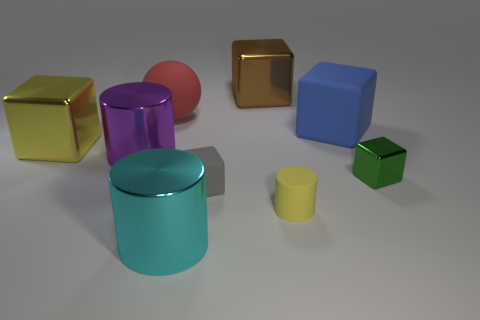How many other things are there of the same color as the rubber cylinder?
Give a very brief answer. 1. There is a cyan metallic cylinder; is it the same size as the yellow object that is in front of the yellow metallic object?
Your answer should be compact. No. What number of yellow matte things are there?
Keep it short and to the point. 1. Do the yellow object on the right side of the red rubber ball and the matte thing on the left side of the tiny gray object have the same size?
Offer a terse response. No. There is a big matte thing that is the same shape as the yellow metal object; what color is it?
Ensure brevity in your answer.  Blue. Does the big brown metallic thing have the same shape as the cyan metal object?
Give a very brief answer. No. There is another rubber thing that is the same shape as the big cyan thing; what is its size?
Ensure brevity in your answer.  Small. What number of cyan cylinders are the same material as the large red sphere?
Make the answer very short. 0. What number of objects are big brown balls or big yellow metal blocks?
Make the answer very short. 1. There is a yellow object to the left of the gray rubber block; are there any cyan shiny cylinders that are left of it?
Ensure brevity in your answer.  No. 